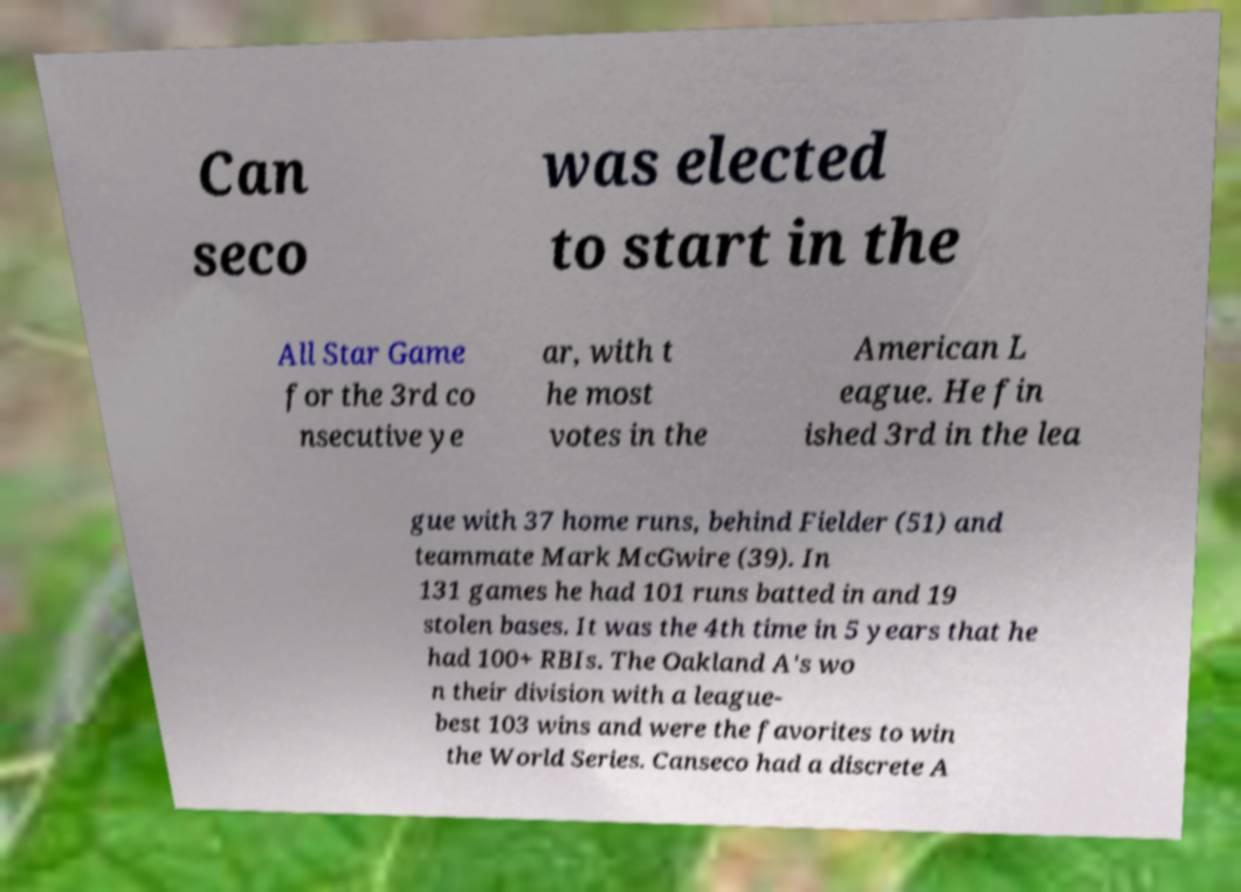Please identify and transcribe the text found in this image. Can seco was elected to start in the All Star Game for the 3rd co nsecutive ye ar, with t he most votes in the American L eague. He fin ished 3rd in the lea gue with 37 home runs, behind Fielder (51) and teammate Mark McGwire (39). In 131 games he had 101 runs batted in and 19 stolen bases. It was the 4th time in 5 years that he had 100+ RBIs. The Oakland A's wo n their division with a league- best 103 wins and were the favorites to win the World Series. Canseco had a discrete A 